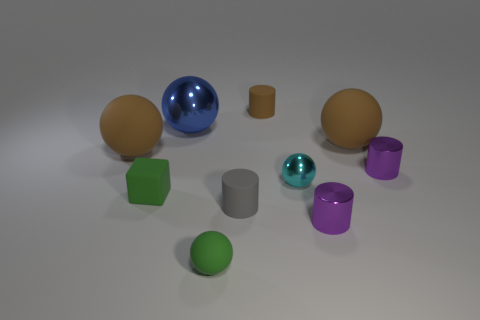There is a brown sphere that is right of the green rubber ball; does it have the same size as the tiny green cube?
Your answer should be compact. No. Are there any metallic cylinders to the left of the large rubber sphere to the right of the gray matte cylinder?
Your answer should be compact. Yes. What is the cyan ball made of?
Give a very brief answer. Metal. Are there any small green spheres behind the small shiny ball?
Provide a succinct answer. No. What is the size of the gray matte object that is the same shape as the tiny brown matte object?
Provide a succinct answer. Small. Are there the same number of cylinders that are behind the brown cylinder and small matte balls behind the blue metal thing?
Offer a very short reply. Yes. What number of small red matte spheres are there?
Your answer should be very brief. 0. Are there more cubes left of the blue shiny thing than big blue metal objects?
Offer a terse response. No. There is a large thing that is on the left side of the large blue ball; what material is it?
Offer a terse response. Rubber. There is a tiny matte object that is the same shape as the big blue thing; what color is it?
Provide a succinct answer. Green. 